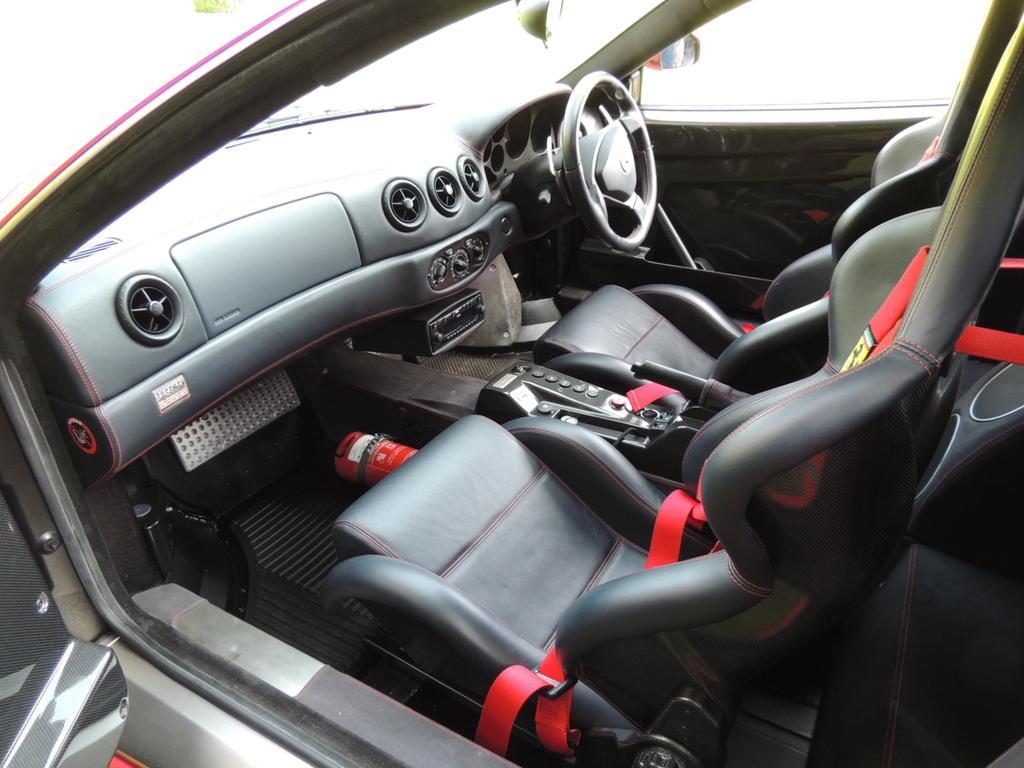How would you summarize this image in a sentence or two? In this picture I can see inside of the car. 